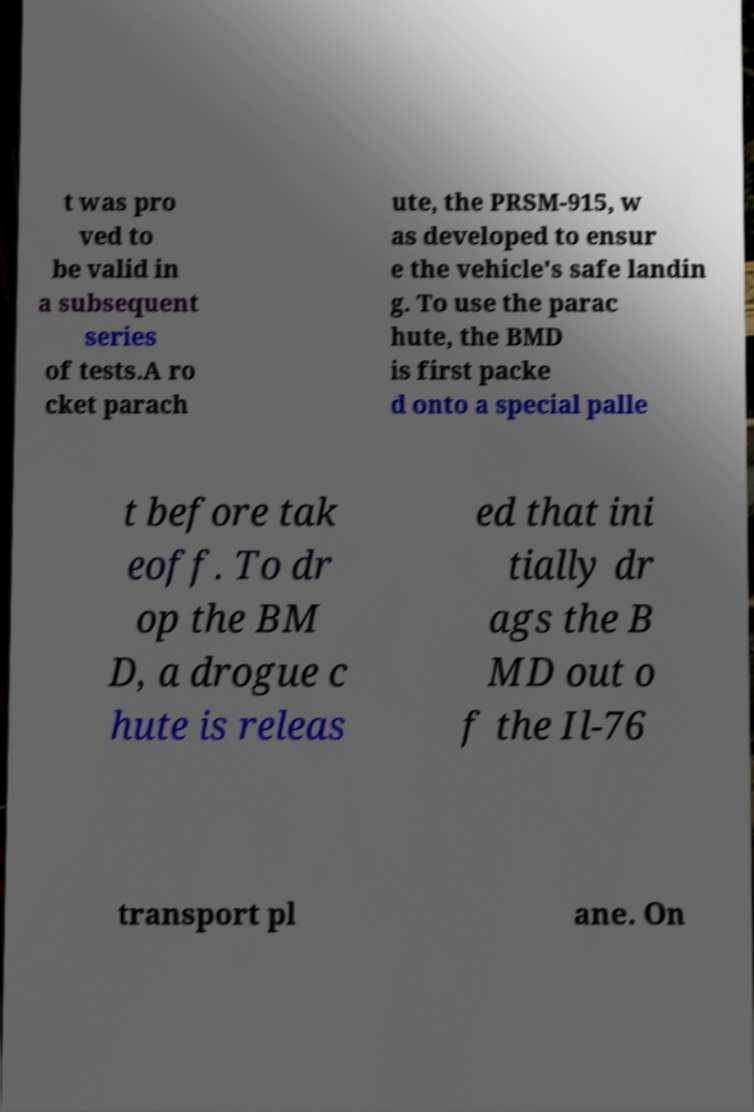There's text embedded in this image that I need extracted. Can you transcribe it verbatim? t was pro ved to be valid in a subsequent series of tests.A ro cket parach ute, the PRSM-915, w as developed to ensur e the vehicle's safe landin g. To use the parac hute, the BMD is first packe d onto a special palle t before tak eoff. To dr op the BM D, a drogue c hute is releas ed that ini tially dr ags the B MD out o f the Il-76 transport pl ane. On 